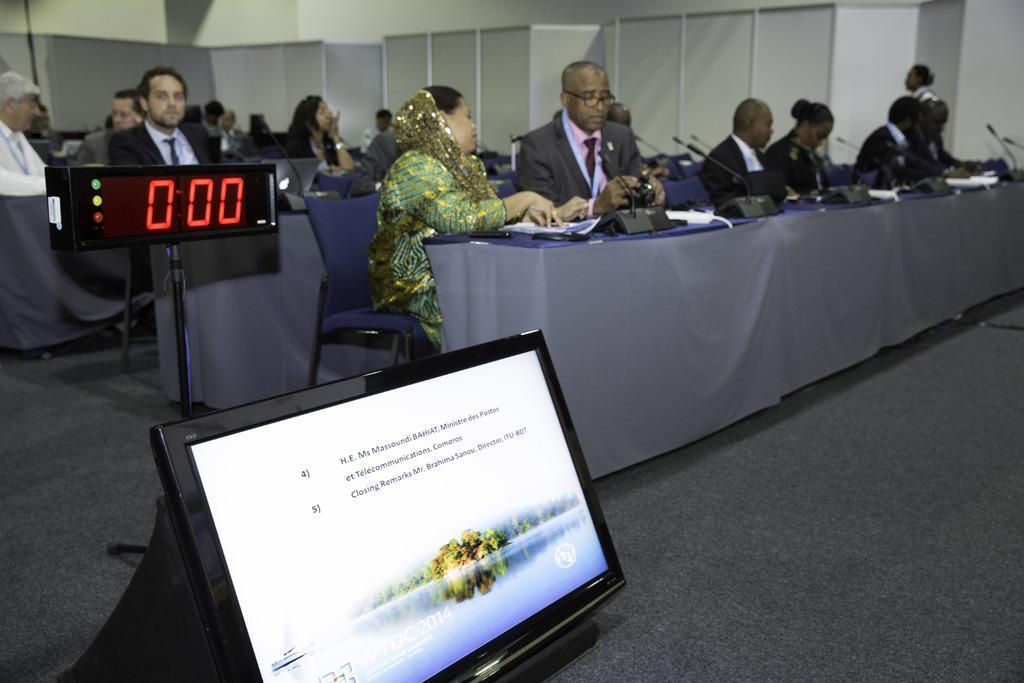Could you give a brief overview of what you see in this image? In this image there are so many people sitting in front of table where we can see there are so many papers and microphones, beside them there is a big digital clock and a computer screen. Also there are some wooden walls behind. 